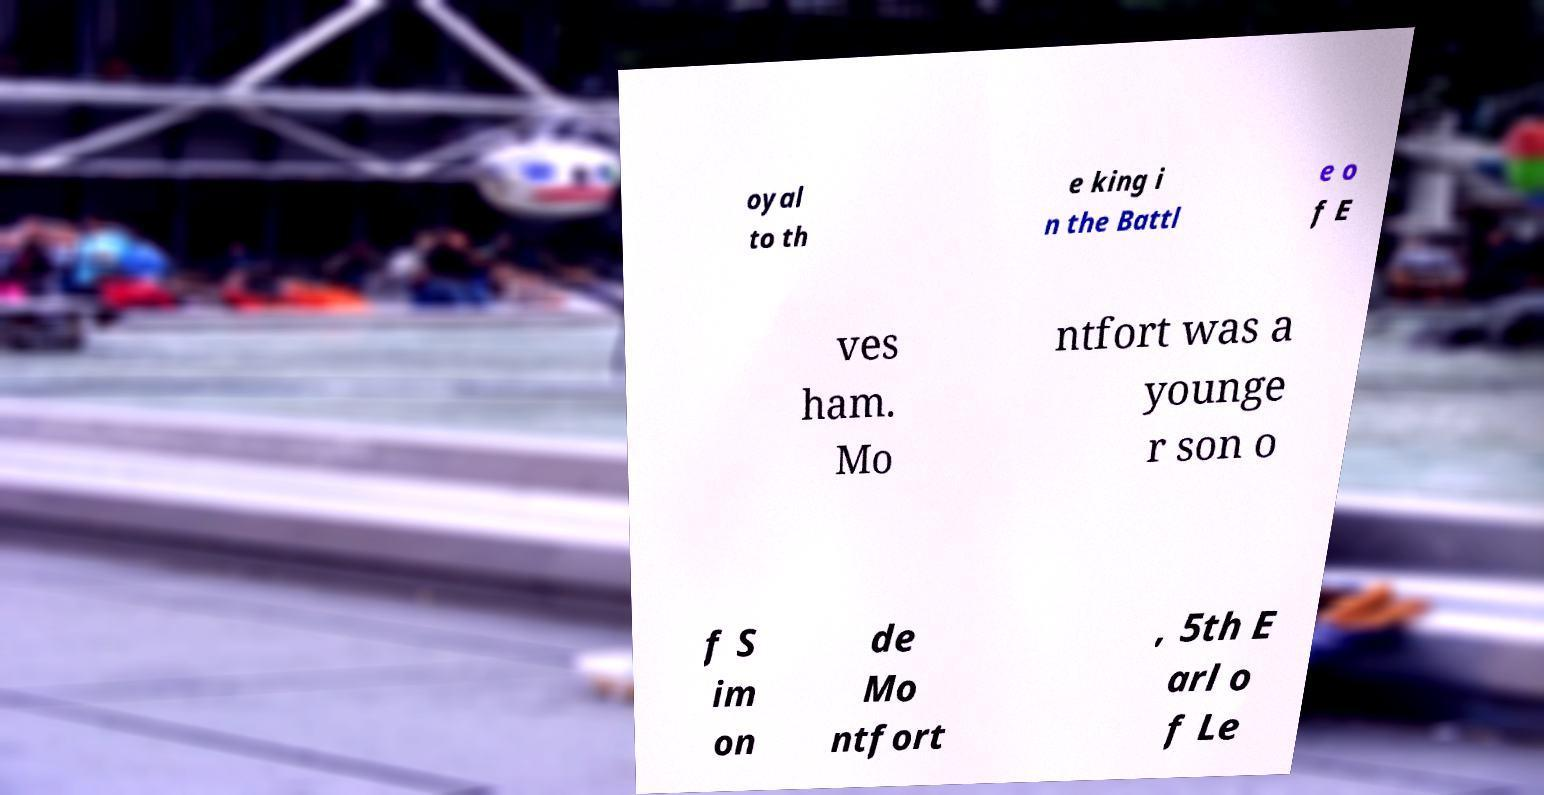Can you accurately transcribe the text from the provided image for me? oyal to th e king i n the Battl e o f E ves ham. Mo ntfort was a younge r son o f S im on de Mo ntfort , 5th E arl o f Le 